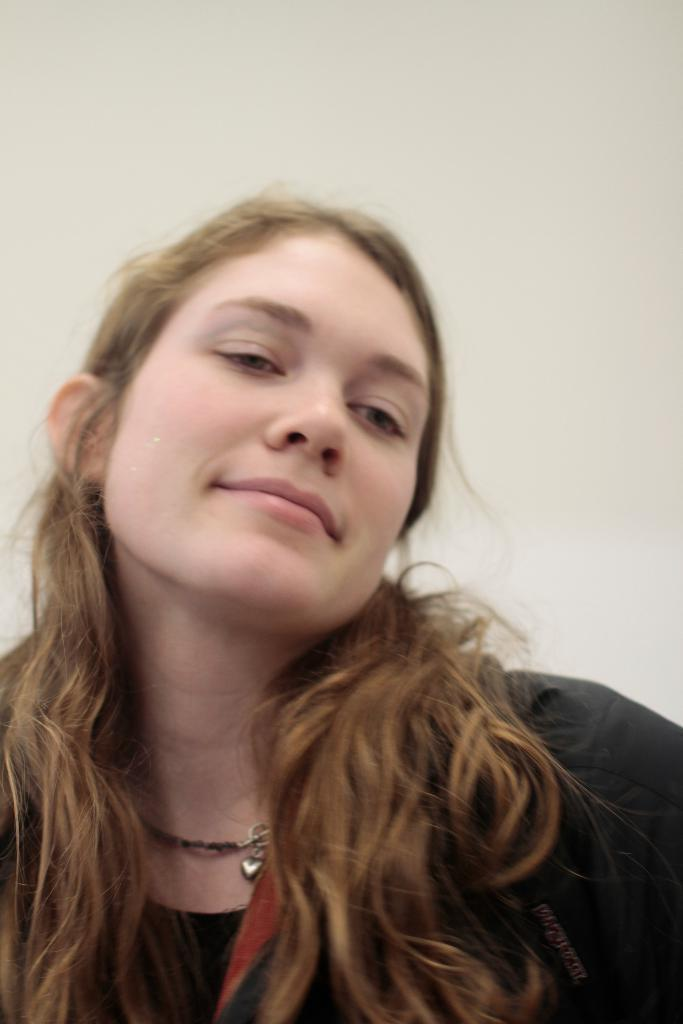Who is present in the image? There is a woman in the image. What is the woman wearing? The woman is wearing a black dress. Can you describe the woman's expression? The woman is smiling. What is visible in the background of the image? There is a white wall in the background of the image. Does the woman have a tail in the image? No, there is no tail present in the image. 